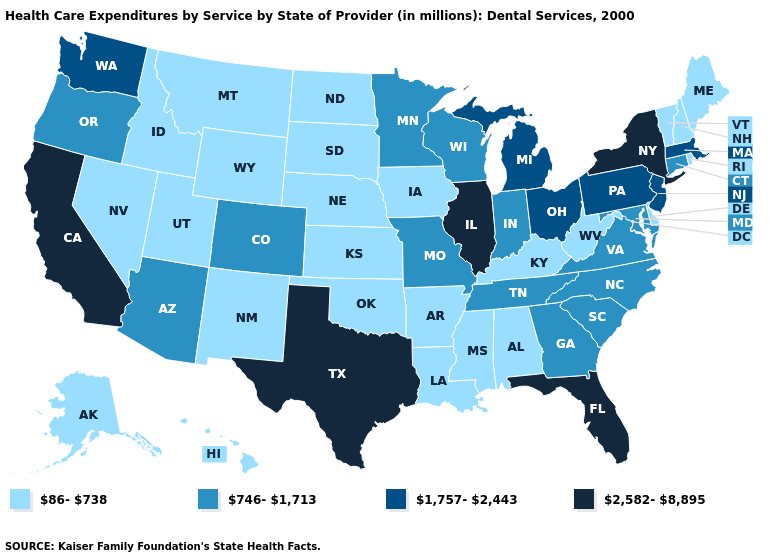What is the lowest value in the USA?
Keep it brief. 86-738. Name the states that have a value in the range 86-738?
Quick response, please. Alabama, Alaska, Arkansas, Delaware, Hawaii, Idaho, Iowa, Kansas, Kentucky, Louisiana, Maine, Mississippi, Montana, Nebraska, Nevada, New Hampshire, New Mexico, North Dakota, Oklahoma, Rhode Island, South Dakota, Utah, Vermont, West Virginia, Wyoming. How many symbols are there in the legend?
Be succinct. 4. How many symbols are there in the legend?
Concise answer only. 4. Name the states that have a value in the range 1,757-2,443?
Be succinct. Massachusetts, Michigan, New Jersey, Ohio, Pennsylvania, Washington. Name the states that have a value in the range 746-1,713?
Keep it brief. Arizona, Colorado, Connecticut, Georgia, Indiana, Maryland, Minnesota, Missouri, North Carolina, Oregon, South Carolina, Tennessee, Virginia, Wisconsin. What is the lowest value in the USA?
Short answer required. 86-738. Name the states that have a value in the range 746-1,713?
Short answer required. Arizona, Colorado, Connecticut, Georgia, Indiana, Maryland, Minnesota, Missouri, North Carolina, Oregon, South Carolina, Tennessee, Virginia, Wisconsin. Name the states that have a value in the range 86-738?
Keep it brief. Alabama, Alaska, Arkansas, Delaware, Hawaii, Idaho, Iowa, Kansas, Kentucky, Louisiana, Maine, Mississippi, Montana, Nebraska, Nevada, New Hampshire, New Mexico, North Dakota, Oklahoma, Rhode Island, South Dakota, Utah, Vermont, West Virginia, Wyoming. What is the value of Virginia?
Concise answer only. 746-1,713. What is the value of Ohio?
Be succinct. 1,757-2,443. Does Tennessee have a lower value than California?
Concise answer only. Yes. Does New York have the highest value in the Northeast?
Be succinct. Yes. What is the value of Arizona?
Give a very brief answer. 746-1,713. Among the states that border Pennsylvania , does West Virginia have the lowest value?
Keep it brief. Yes. 